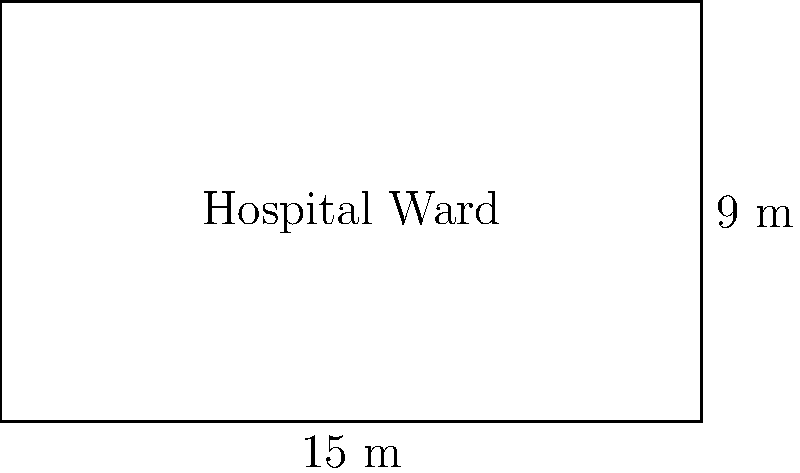As a public health student in Indonesia, you are assisting in the planning of a new hospital ward. The rectangular ward has dimensions of 15 meters in length and 9 meters in width. Calculate the total floor area of the ward in square meters. To calculate the area of a rectangular hospital ward, we need to multiply its length by its width. Let's follow these steps:

1. Identify the given dimensions:
   - Length = 15 meters
   - Width = 9 meters

2. Apply the formula for the area of a rectangle:
   $$ \text{Area} = \text{Length} \times \text{Width} $$

3. Substitute the values into the formula:
   $$ \text{Area} = 15 \text{ m} \times 9 \text{ m} $$

4. Perform the multiplication:
   $$ \text{Area} = 135 \text{ m}^2 $$

Therefore, the total floor area of the hospital ward is 135 square meters.
Answer: 135 m² 